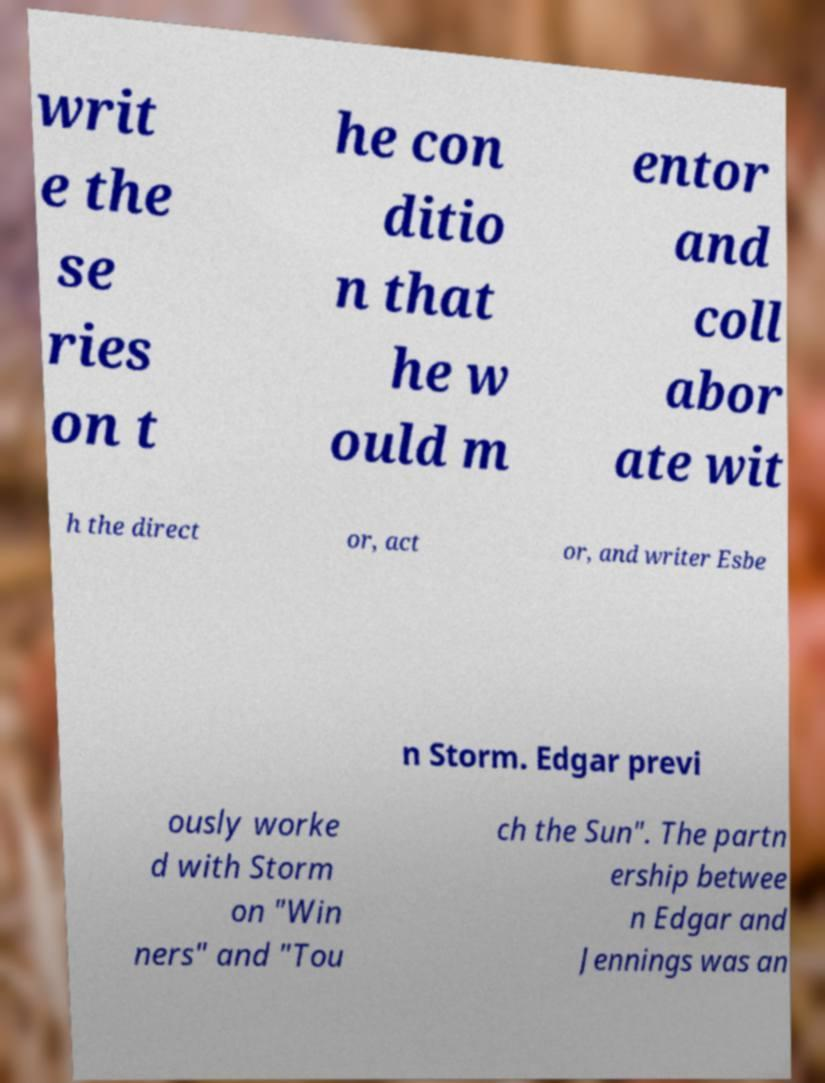Please identify and transcribe the text found in this image. writ e the se ries on t he con ditio n that he w ould m entor and coll abor ate wit h the direct or, act or, and writer Esbe n Storm. Edgar previ ously worke d with Storm on "Win ners" and "Tou ch the Sun". The partn ership betwee n Edgar and Jennings was an 